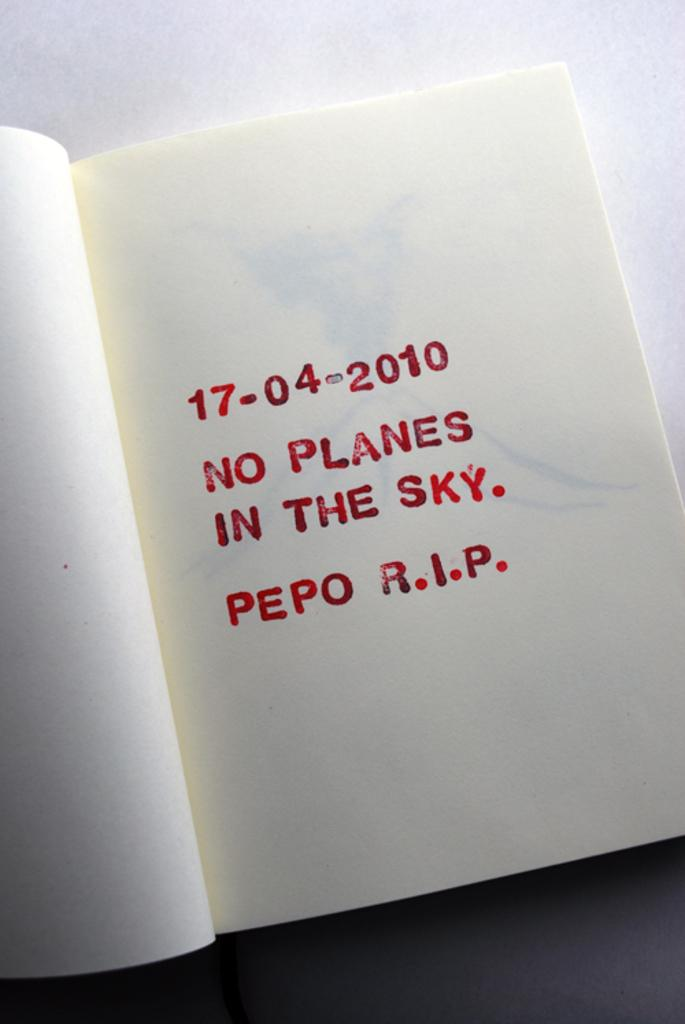<image>
Create a compact narrative representing the image presented. A book is open to a page with the date 17-04-2010. 